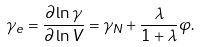<formula> <loc_0><loc_0><loc_500><loc_500>\gamma _ { e } = \frac { \partial \ln \gamma } { \partial \ln V } = \gamma _ { N } + \frac { \lambda } { 1 + \lambda } \varphi .</formula> 